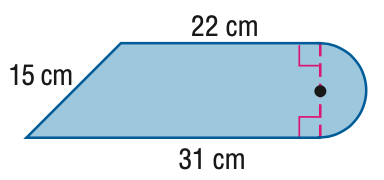Question: Find the area of the figure. Round to the nearest tenth if necessary.
Choices:
A. 374.5
B. 431.1
C. 692.5
D. 749.1
Answer with the letter. Answer: A 